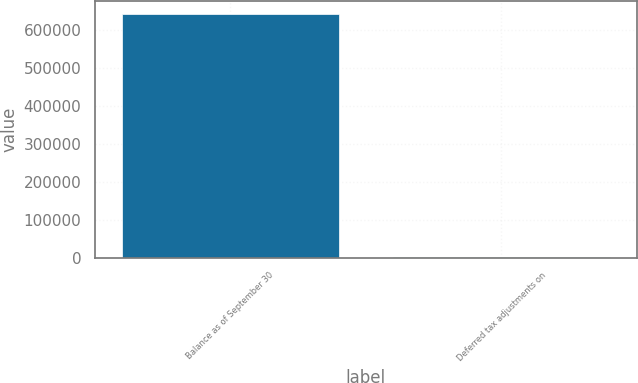Convert chart to OTSL. <chart><loc_0><loc_0><loc_500><loc_500><bar_chart><fcel>Balance as of September 30<fcel>Deferred tax adjustments on<nl><fcel>642616<fcel>419<nl></chart> 